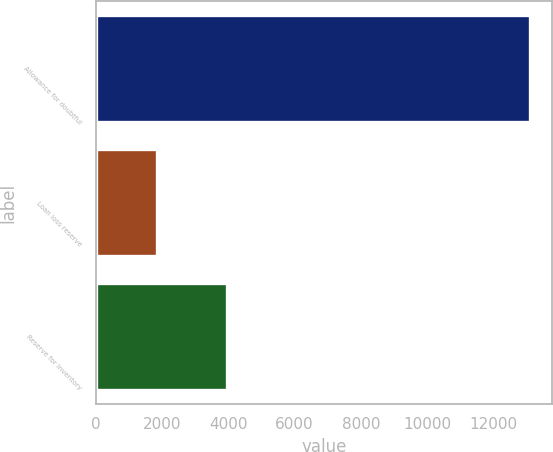<chart> <loc_0><loc_0><loc_500><loc_500><bar_chart><fcel>Allowance for doubtful<fcel>Loan loss reserve<fcel>Reserve for inventory<nl><fcel>13109<fcel>1839<fcel>3947<nl></chart> 